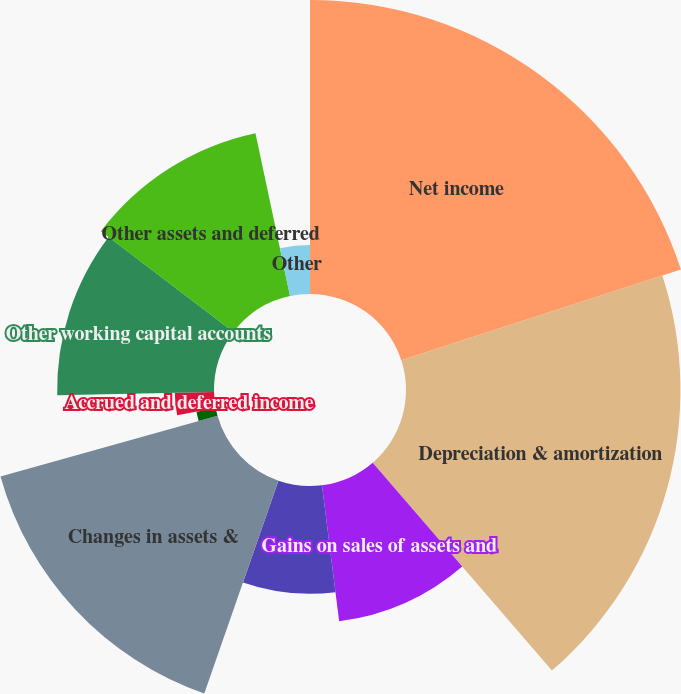<chart> <loc_0><loc_0><loc_500><loc_500><pie_chart><fcel>Net income<fcel>Depreciation & amortization<fcel>Gains on sales of assets and<fcel>Stock-based compensation<fcel>Changes in assets &<fcel>Accrued interest<fcel>Accrued and deferred income<fcel>Other working capital accounts<fcel>Other assets and deferred<fcel>Other<nl><fcel>20.0%<fcel>18.67%<fcel>9.33%<fcel>7.33%<fcel>15.33%<fcel>1.33%<fcel>2.67%<fcel>10.67%<fcel>11.33%<fcel>3.33%<nl></chart> 